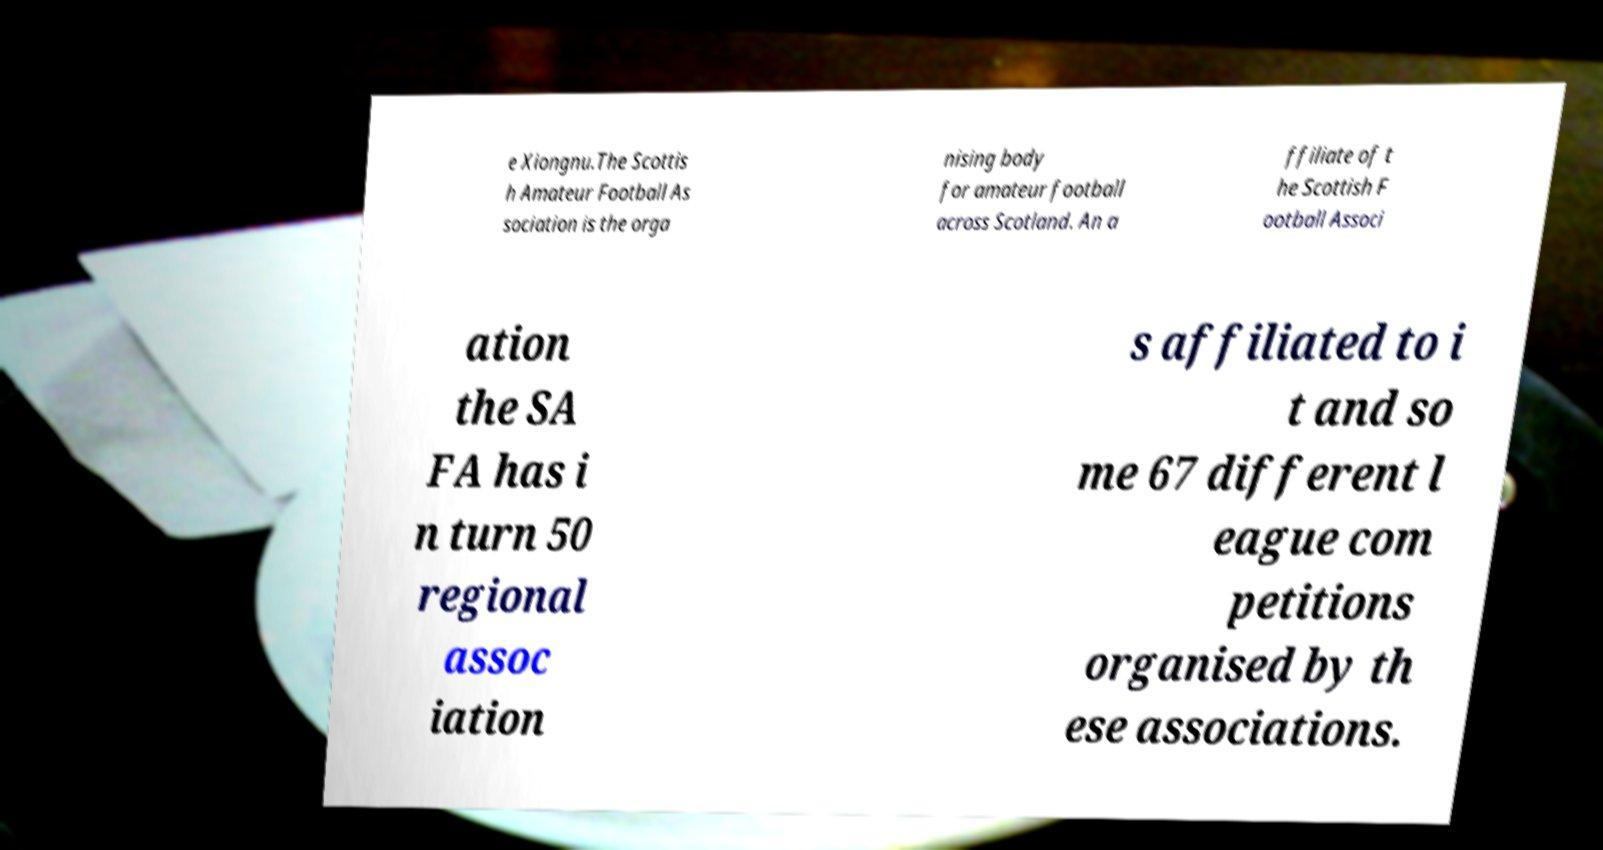Can you accurately transcribe the text from the provided image for me? e Xiongnu.The Scottis h Amateur Football As sociation is the orga nising body for amateur football across Scotland. An a ffiliate of t he Scottish F ootball Associ ation the SA FA has i n turn 50 regional assoc iation s affiliated to i t and so me 67 different l eague com petitions organised by th ese associations. 